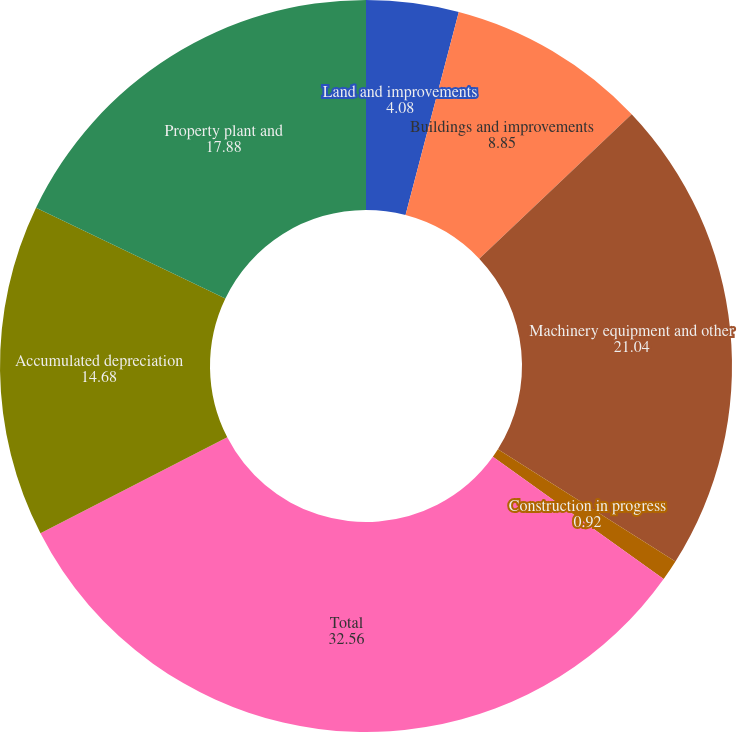<chart> <loc_0><loc_0><loc_500><loc_500><pie_chart><fcel>Land and improvements<fcel>Buildings and improvements<fcel>Machinery equipment and other<fcel>Construction in progress<fcel>Total<fcel>Accumulated depreciation<fcel>Property plant and<nl><fcel>4.08%<fcel>8.85%<fcel>21.04%<fcel>0.92%<fcel>32.56%<fcel>14.68%<fcel>17.88%<nl></chart> 